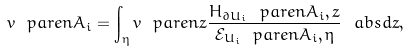Convert formula to latex. <formula><loc_0><loc_0><loc_500><loc_500>v \ p a r e n { A _ { i } } = \int _ { \eta } v \ p a r e n { z } \frac { H _ { \partial U _ { i } } \ p a r e n { A _ { i } , z } } { \mathcal { E } _ { U _ { i } } \ p a r e n { A _ { i } , \eta } } \ a b s { d z } ,</formula> 